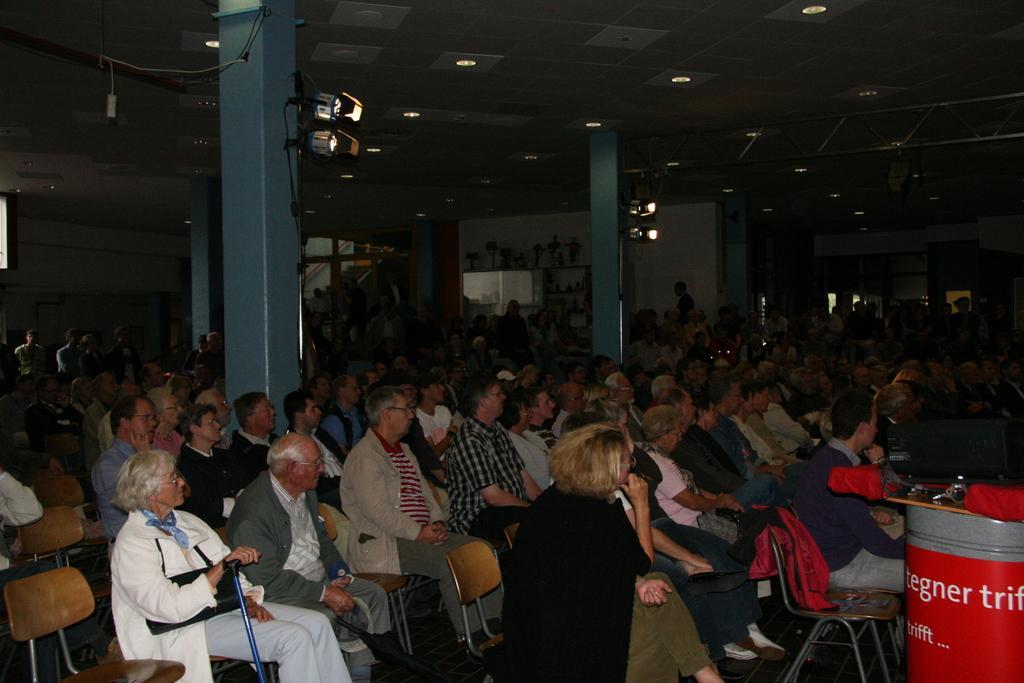Can you describe this image briefly? In this image some crowd sitting in chairs in a room. There are four pillars in middle of them. There are two lights for each of two pillars. To the bottom right there is a drum. 